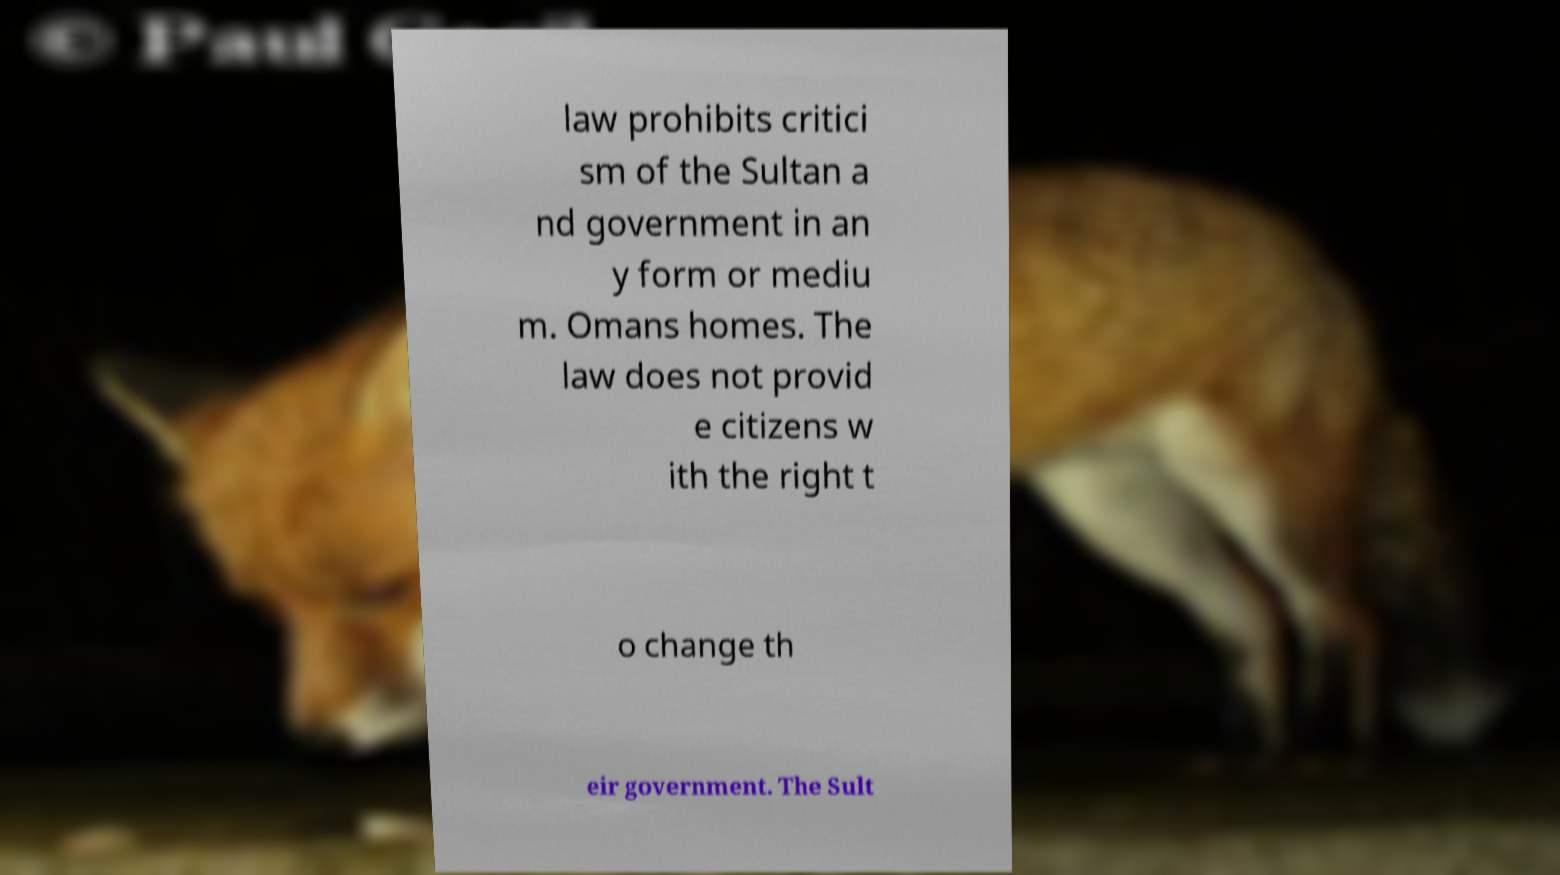Can you accurately transcribe the text from the provided image for me? law prohibits critici sm of the Sultan a nd government in an y form or mediu m. Omans homes. The law does not provid e citizens w ith the right t o change th eir government. The Sult 